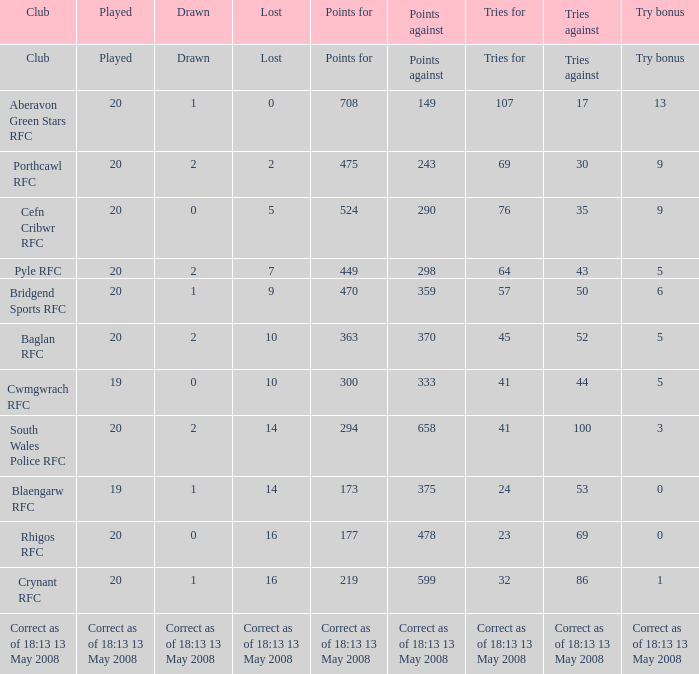Can you give me this table as a dict? {'header': ['Club', 'Played', 'Drawn', 'Lost', 'Points for', 'Points against', 'Tries for', 'Tries against', 'Try bonus'], 'rows': [['Club', 'Played', 'Drawn', 'Lost', 'Points for', 'Points against', 'Tries for', 'Tries against', 'Try bonus'], ['Aberavon Green Stars RFC', '20', '1', '0', '708', '149', '107', '17', '13'], ['Porthcawl RFC', '20', '2', '2', '475', '243', '69', '30', '9'], ['Cefn Cribwr RFC', '20', '0', '5', '524', '290', '76', '35', '9'], ['Pyle RFC', '20', '2', '7', '449', '298', '64', '43', '5'], ['Bridgend Sports RFC', '20', '1', '9', '470', '359', '57', '50', '6'], ['Baglan RFC', '20', '2', '10', '363', '370', '45', '52', '5'], ['Cwmgwrach RFC', '19', '0', '10', '300', '333', '41', '44', '5'], ['South Wales Police RFC', '20', '2', '14', '294', '658', '41', '100', '3'], ['Blaengarw RFC', '19', '1', '14', '173', '375', '24', '53', '0'], ['Rhigos RFC', '20', '0', '16', '177', '478', '23', '69', '0'], ['Crynant RFC', '20', '1', '16', '219', '599', '32', '86', '1'], ['Correct as of 18:13 13 May 2008', 'Correct as of 18:13 13 May 2008', 'Correct as of 18:13 13 May 2008', 'Correct as of 18:13 13 May 2008', 'Correct as of 18:13 13 May 2008', 'Correct as of 18:13 13 May 2008', 'Correct as of 18:13 13 May 2008', 'Correct as of 18:13 13 May 2008', 'Correct as of 18:13 13 May 2008']]} What is the deficit when the attempt reward is 5, and points against is 298? 7.0. 